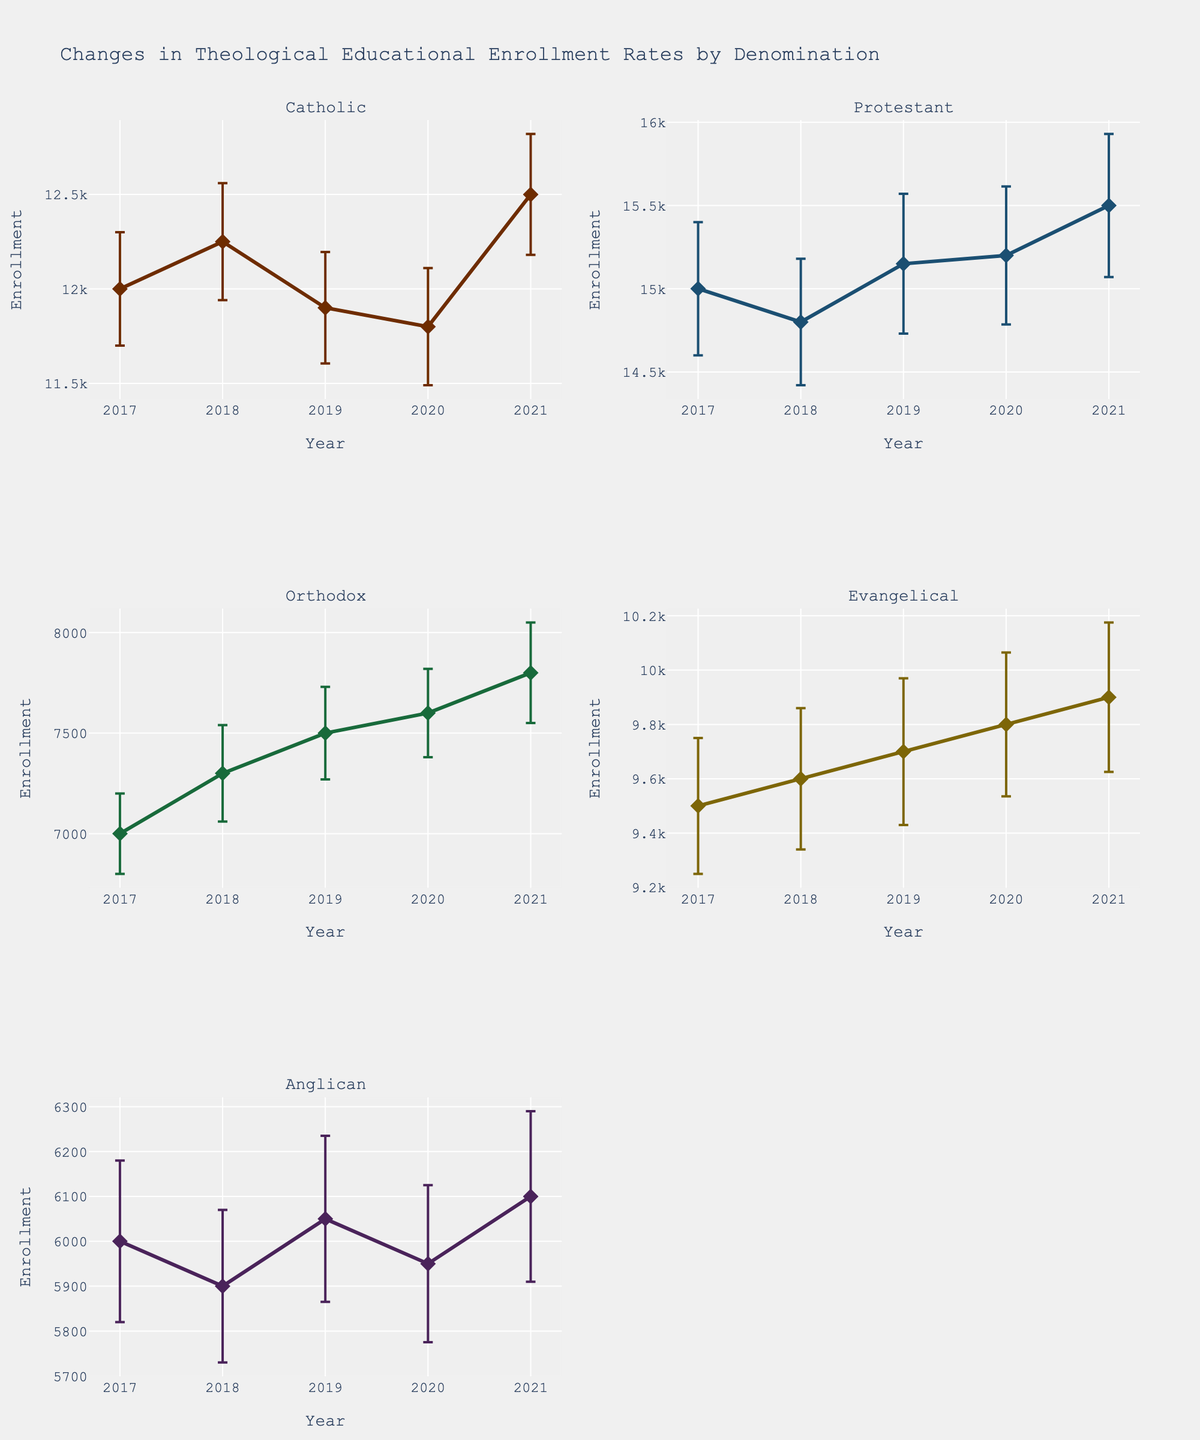What is the title of the plot? The title of the plot is displayed at the top of the figure. It summarizes the content being presented in the subplots.
Answer: Changes in Theological Educational Enrollment Rates by Denomination What is the enrollment trend for the Catholic denomination from 2017 to 2021? To identify the trend, look at the increasing or decreasing pattern of data points for the Catholic denomination in the plot. The line generally shows an increase in enrollment over the years 2017 to 2021.
Answer: Increasing In 2021, which denomination had the highest enrollment? Check the data points for each denomination in 2021 and identify the highest value among them. Protestant has the highest enrollment in 2021.
Answer: Protestant Which year shows the most significant confidence interval for Catholic enrollment? Compare the extents of the error bars (confidence intervals) for Catholic enrollment across all years. Find the year with the longest error bars.
Answer: 2021 How does the 2019 enrollment for Orthodox compare with that of Evangelical? Check the y-values for Orthodox and Evangelical in 2019 and compare them. Orthodox enrollment was 7500, and Evangelical was 9700. Hence, Evangelical had higher enrollment than Orthodox in 2019.
Answer: Evangelical What is the average enrollment of the Anglican denomination over the years from 2017 to 2021? Sum the enrollment values of Anglican for the years 2017 to 2021 and divide by the number of years (5). (6000 + 5900 + 6050 + 5950 + 6100) / 5 = 30000 / 5 = 6000
Answer: 6000 Which denomination has the smallest standard deviation in 2020? Check the standard deviation values for each denomination in 2020. Find the smallest value, which refers to the denomination with the smallest standard deviation.
Answer: Orthodox Between Evangelical and Orthodox denominations in 2018, which one has the larger confidence interval? Look at the lengths of the error bars for both Evangelical and Orthodox denominations in 2018. The confidence interval for Orthodox (7300 ± 240) is smaller than that for Evangelical (9600 ± 260).
Answer: Evangelical Has the enrollment for Anglican increased or decreased from 2017 to 2018? Compare the enrollment value for Anglican in 2017 with that in 2018. In 2017 it was 6000, and in 2018 it was 5900, showing a decrease.
Answer: Decreased Which denomination had the most stable enrollment (smallest standard deviation) over the years among the five denominations? Examine and compare the standard deviations for each denomination across the years. The denomination with the smallest overall standard deviation is the most stable.
Answer: Orthodox 